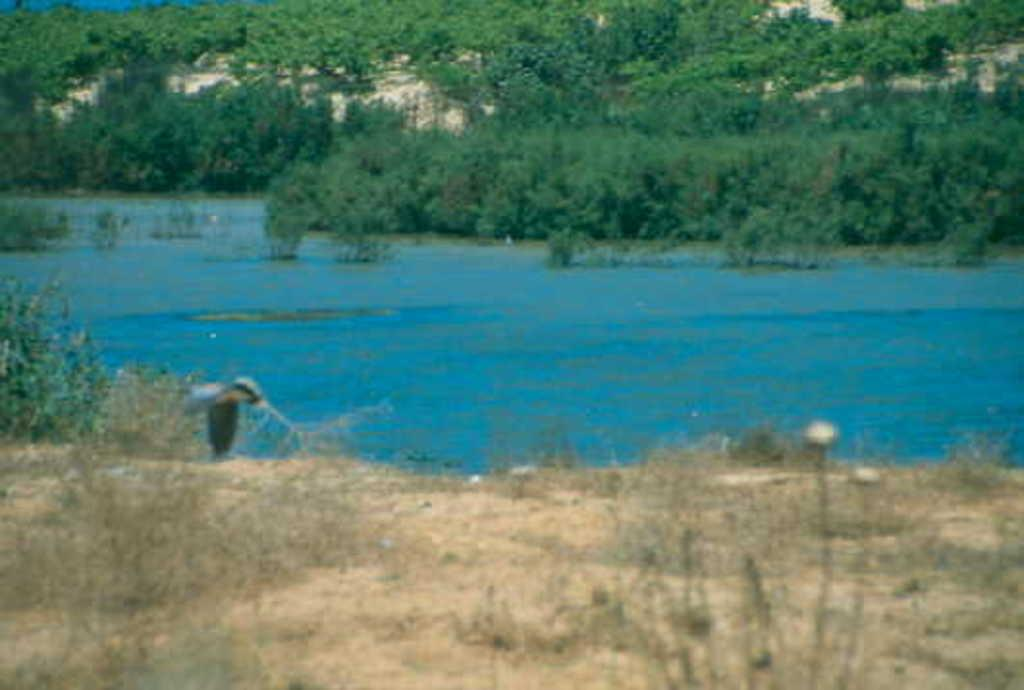What type of vegetation is on the ground in the image? There are plants on the ground in the image. What natural element is visible in the image? There is water visible in the image. What can be seen in the background of the image? There are trees in the background of the image. What type of metal can be seen in the image? There is no metal present in the image; it features plants on the ground, water, and trees in the background. How many cents are visible in the image? There are no cents present in the image. 